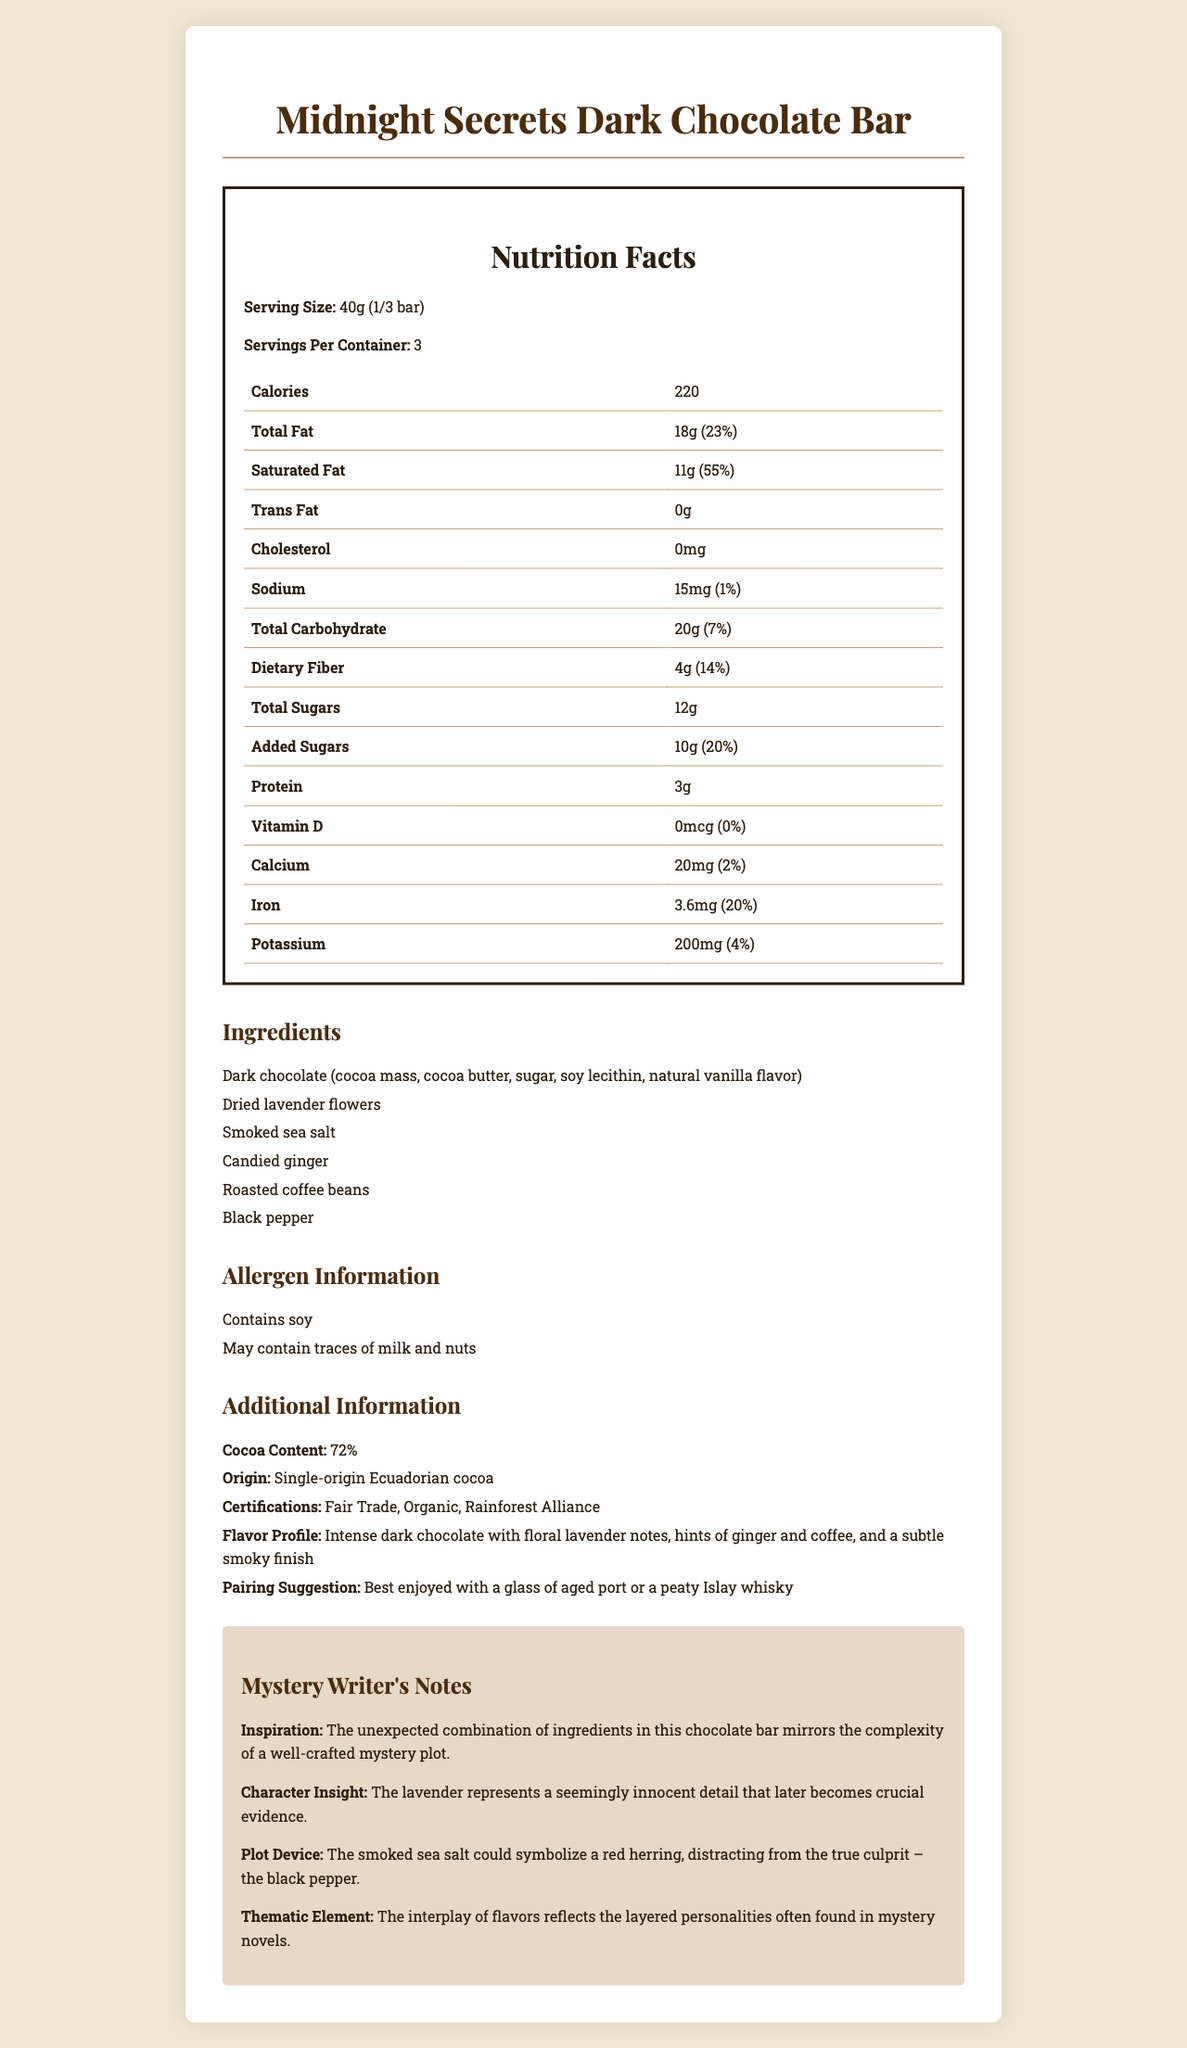what is the serving size? The serving size is listed at the top of the nutritional facts section and is specified as 40g, which equals 1/3 of the bar.
Answer: 40g (1/3 bar) how many servings are there per container? The number of servings per container is stated as 3 in the nutritional facts section.
Answer: 3 what is the total fat content per serving? The total fat content is listed as 18g per serving in the nutritional facts section.
Answer: 18g how much iron does one serving contain? The amount of iron per serving is given as 3.6mg in the nutritional table.
Answer: 3.6mg does this product contain cholesterol? The cholesterol content is listed as 0mg, indicating that the product contains no cholesterol.
Answer: No what is the flavor profile of the chocolate bar? The additional information lists the flavor profile as being complex with multiple notes.
Answer: Intense dark chocolate with floral lavender notes, hints of ginger and coffee, and a subtle smoky finish how much of your daily saturated fat intake does one serving provide? One serving provides 55% of the daily value for saturated fat, as listed in the nutritional facts.
Answer: 55% what allergens are present in the product? The allergens section lists soy, and it warns that the product may contain traces of milk and nuts.
Answer: Contains soy; May contain traces of milk and nuts how many grams of dietary fiber are in one serving? The dietary fiber content per serving is stated as 4g in the nutritional facts.
Answer: 4g which of the following ingredients is not in the chocolate bar? A. Dried lavender flowers B. Smoked sea salt C. Cinnamon D. Candied ginger The ingredient list includes dried lavender flowers, smoked sea salt, and candied ginger but does not mention cinnamon.
Answer: C which certificate does the product have? I. Fair Trade II. Kosher III. Organic IV. Rainforest Alliance The additional information mentions that the product is Fair Trade, Organic, and Rainforest Alliance certified, but does not list Kosher certification.
Answer: I, III, IV does this chocolate bar have any added sugars? The nutritional facts indicate that there are 10g of added sugars per serving.
Answer: Yes summarize the main idea of the document. The document aims to comprehensively inform consumers about the chocolate bar's nutrition, unique ingredients, flavor, certifications, and provides a creative perspective relating the ingredients to elements of a mystery storyline.
Answer: The document provides detailed nutritional information and ingredient list for the "Midnight Secrets Dark Chocolate Bar", which features unique ingredients such as dried lavender flowers, smoked sea salt, and roasted coffee beans. It also includes allergen information, additional product details like cocoa content and certifications, flavor profile, pairing suggestions, and thematic notes from a mystery writer. what was the source of inspiration for the mystery writer's notes? The mystery writer noted that the inspiration was the complex blend of surprising ingredients, likening it to the twists and turns in a mystery plot.
Answer: The unexpected combination of ingredients in this chocolate bar mirrors the complexity of a well-crafted mystery plot. what is the sodium content in one serving? The nutritional facts list the sodium content as 15mg per serving.
Answer: 15mg how much calcium is present in a serving, and what percentage of the daily value does it represent? The calcium content per serving is 20mg, which represents 2% of the daily recommended value.
Answer: 20mg, 2% can we determine the manufacturing date of this product? The document does not provide information about the manufacturing date of the product.
Answer: Not enough information 